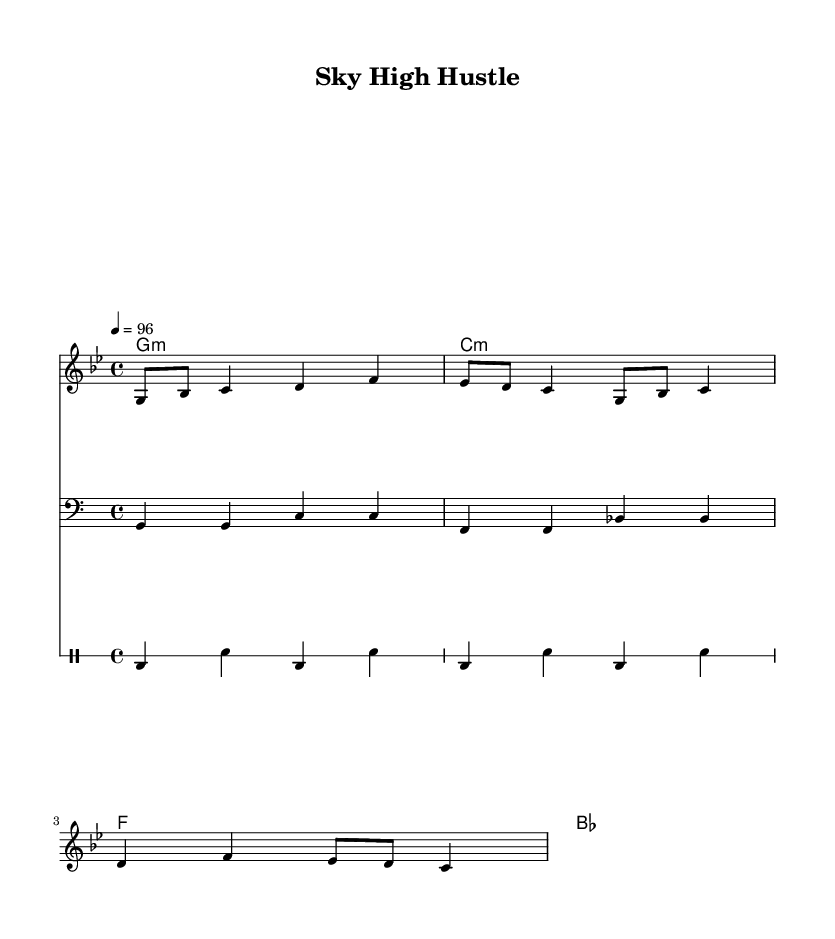What is the key signature of this music? The key signature is G minor, indicated by two flats (B♭ and E♭) in the key signature line.
Answer: G minor What is the time signature of this music? The time signature is 4/4, which shows there are four beats in each measure and the quarter note gets one beat.
Answer: 4/4 What is the tempo marking of the piece? The tempo marking is 4 = 96, meaning that there are 96 beats per minute, and each quarter note gets one beat.
Answer: 96 How many measures are in the melody section? The melody section contains three complete measures, each indicated by vertical bar lines separating the musical phrases.
Answer: 3 What type of chord progression is used in the harmonies? The chord progression is a minor progression, starting with G minor, followed by C minor, then F major, and B♭ major, typical for Latin music.
Answer: Minor progression What is the vocal theme of the lyrics? The lyrics reference the fast-paced life of flight crews, mentioning "jet fuel" and "time zones," encapsulating the experience of flying.
Answer: Fast-paced life of flight crews What forms of rhythm are used in the drum section? The drum section consists of a bass drum and snare rhythm pattern that alternates, creating a driving beat typical in reggaeton music.
Answer: Bass and snare rhythm 